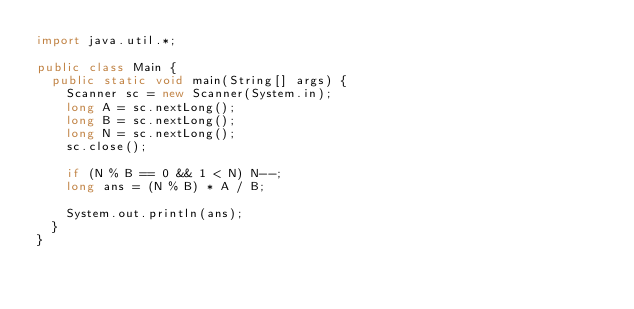Convert code to text. <code><loc_0><loc_0><loc_500><loc_500><_Java_>import java.util.*;

public class Main {
  public static void main(String[] args) {
    Scanner sc = new Scanner(System.in);
    long A = sc.nextLong();
    long B = sc.nextLong();
    long N = sc.nextLong();
    sc.close();

    if (N % B == 0 && 1 < N) N--;
    long ans = (N % B) * A / B;

    System.out.println(ans);
  }
}
</code> 